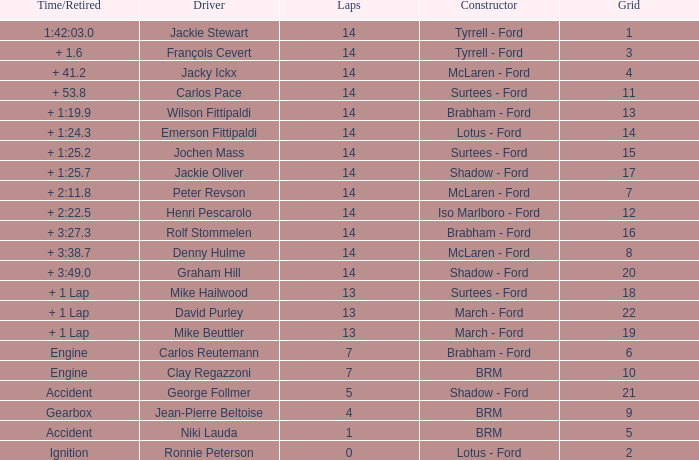What is the low lap total for a grid larger than 16 and has a Time/Retired of + 3:27.3? None. 